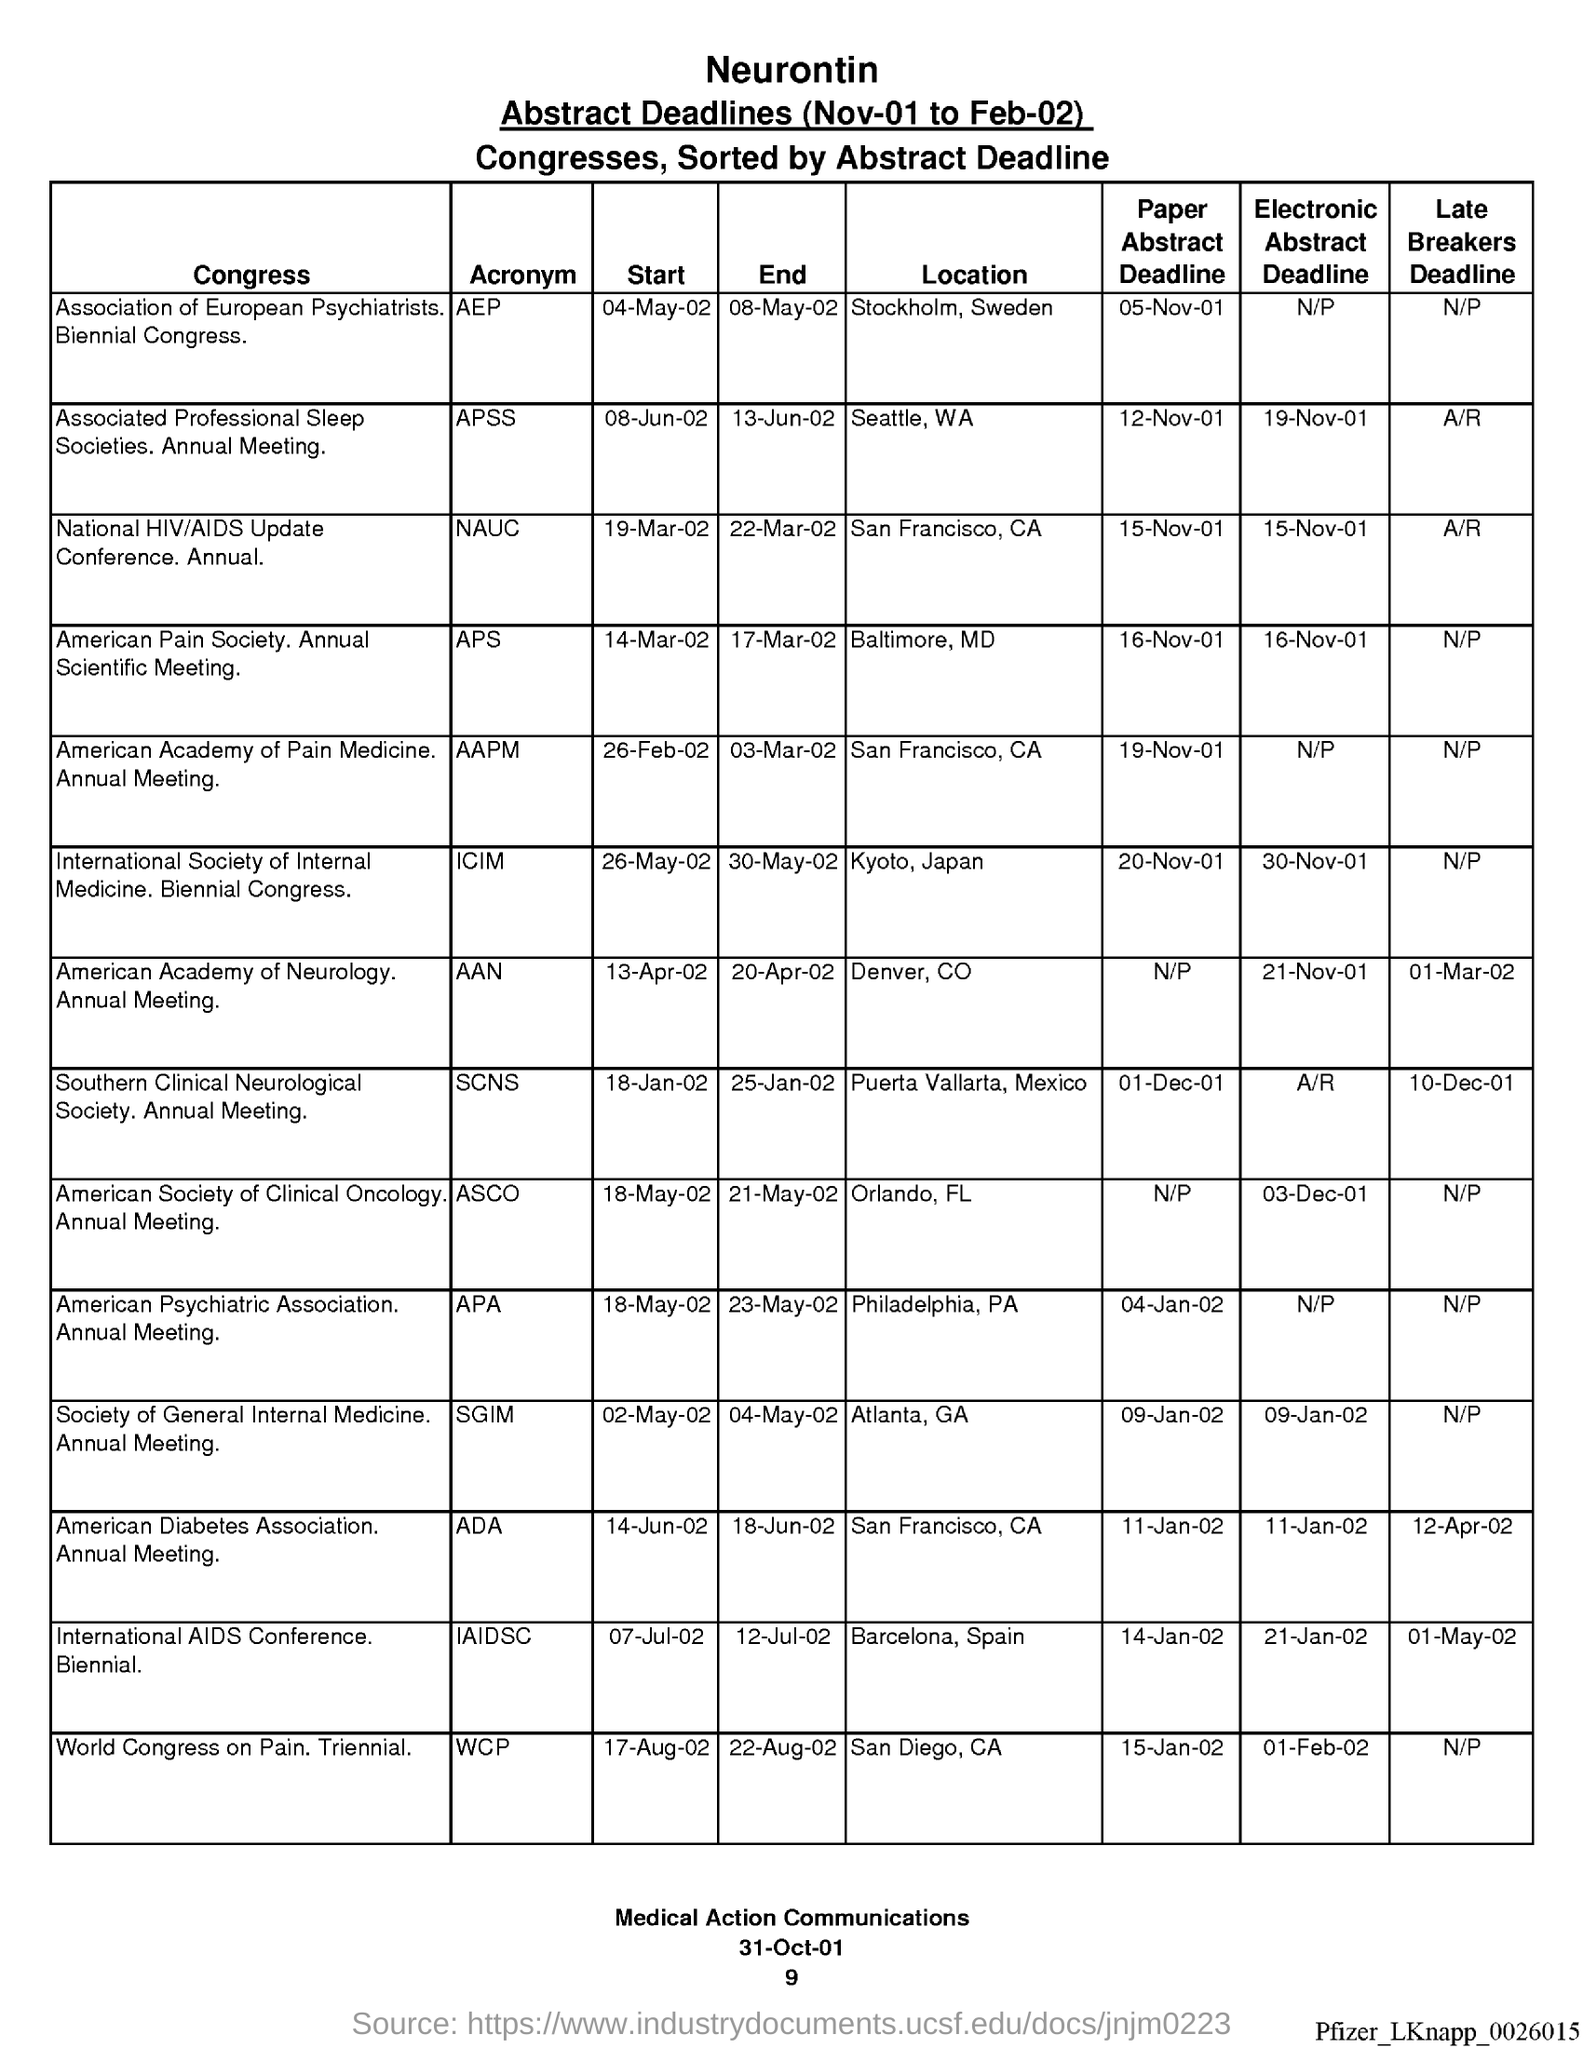Give some essential details in this illustration. The acronym for the American Academy of Pain Medicine is AAPM. NAUC is the acronym for National HIV/AIDS Update. The acronym for the Southern Clinical Neurological Society is SCNS. The acronym for the Association of European Psychiatrists is AEP. The acronym for the American Pain Society is APS. 